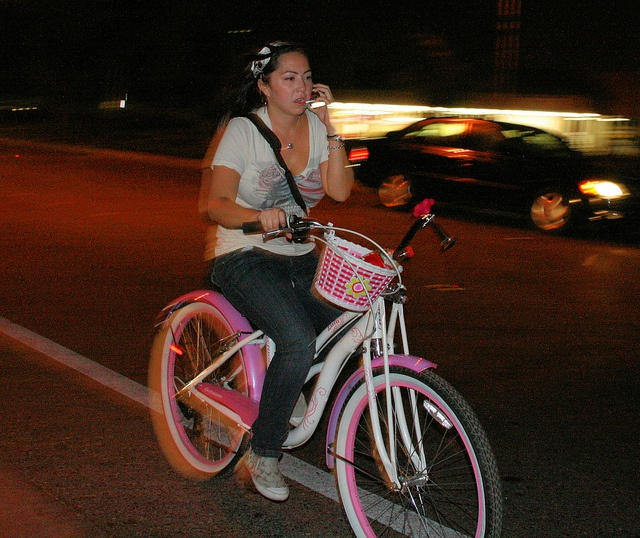Describe the objects in this image and their specific colors. I can see bicycle in black, darkgray, maroon, and gray tones, people in black, darkgray, brown, and gray tones, car in black, maroon, and brown tones, handbag in black, maroon, darkgray, and gray tones, and cell phone in black, maroon, and gray tones in this image. 